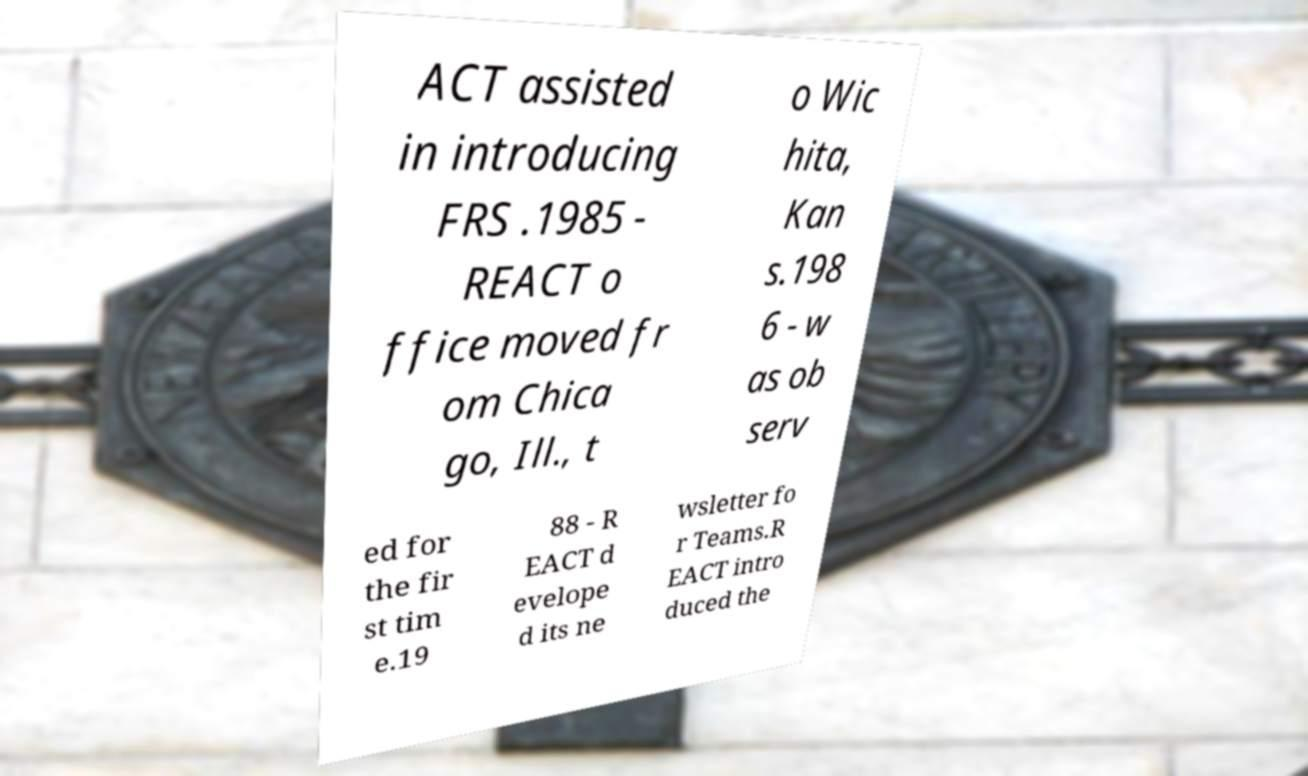Could you assist in decoding the text presented in this image and type it out clearly? ACT assisted in introducing FRS .1985 - REACT o ffice moved fr om Chica go, Ill., t o Wic hita, Kan s.198 6 - w as ob serv ed for the fir st tim e.19 88 - R EACT d evelope d its ne wsletter fo r Teams.R EACT intro duced the 